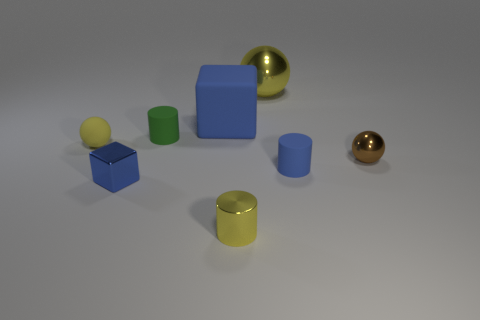What size is the yellow object that is behind the small brown shiny sphere and on the left side of the big yellow ball?
Make the answer very short. Small. What number of metal objects are cubes or purple cylinders?
Make the answer very short. 1. Is the shape of the tiny blue thing to the left of the large yellow metallic sphere the same as the blue matte thing behind the small yellow rubber ball?
Offer a terse response. Yes. Is there a big red sphere that has the same material as the tiny green thing?
Make the answer very short. No. What is the color of the matte sphere?
Your response must be concise. Yellow. There is a thing that is to the left of the small blue shiny thing; how big is it?
Provide a short and direct response. Small. What number of tiny balls have the same color as the rubber block?
Your answer should be compact. 0. Is there a tiny rubber cylinder that is left of the small blue thing on the right side of the small block?
Give a very brief answer. Yes. There is a tiny sphere that is to the left of the small yellow metal thing; does it have the same color as the shiny ball behind the small brown metallic sphere?
Your answer should be compact. Yes. What is the color of the shiny sphere that is the same size as the blue shiny block?
Make the answer very short. Brown. 